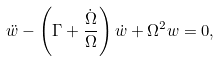Convert formula to latex. <formula><loc_0><loc_0><loc_500><loc_500>\ddot { w } - \left ( \Gamma + \frac { \dot { \Omega } } { \Omega } \right ) \dot { w } + \Omega ^ { 2 } w = 0 ,</formula> 